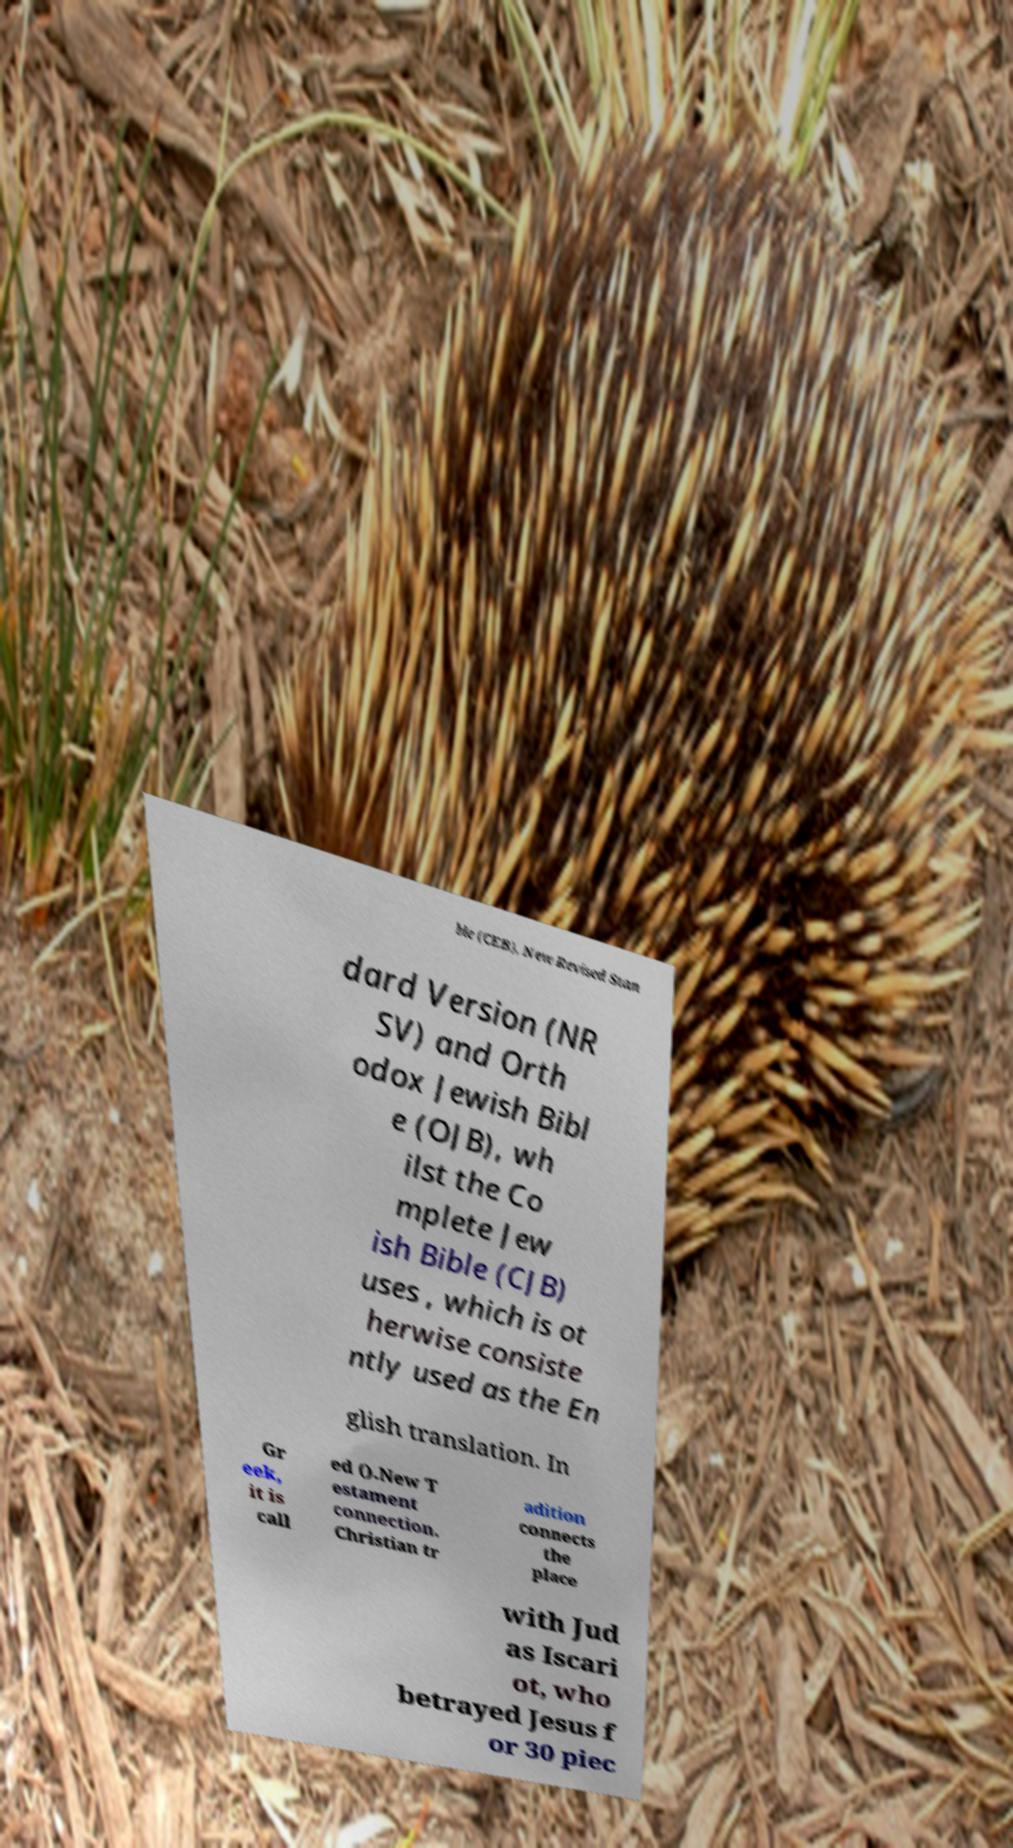Could you extract and type out the text from this image? ble (CEB), New Revised Stan dard Version (NR SV) and Orth odox Jewish Bibl e (OJB), wh ilst the Co mplete Jew ish Bible (CJB) uses , which is ot herwise consiste ntly used as the En glish translation. In Gr eek, it is call ed ().New T estament connection. Christian tr adition connects the place with Jud as Iscari ot, who betrayed Jesus f or 30 piec 